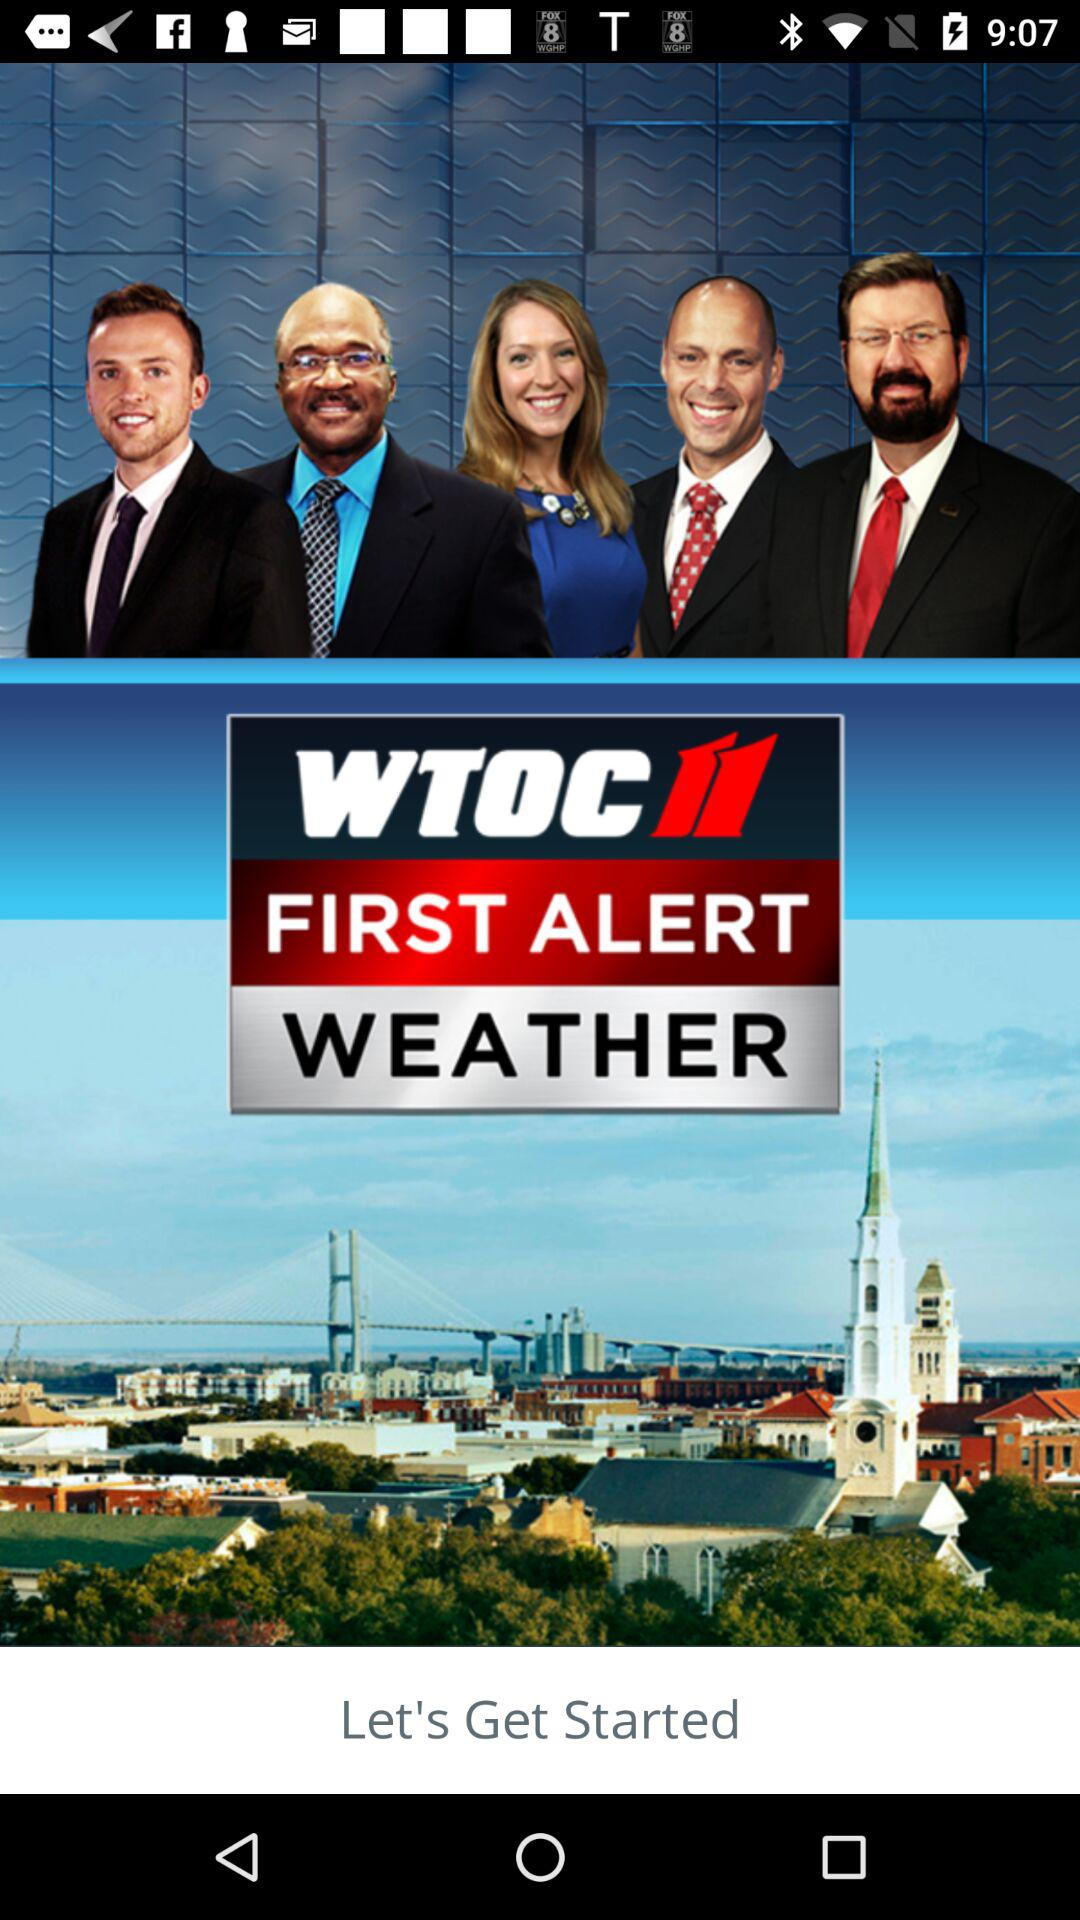What is the application name? The application name is "WTOC11". 